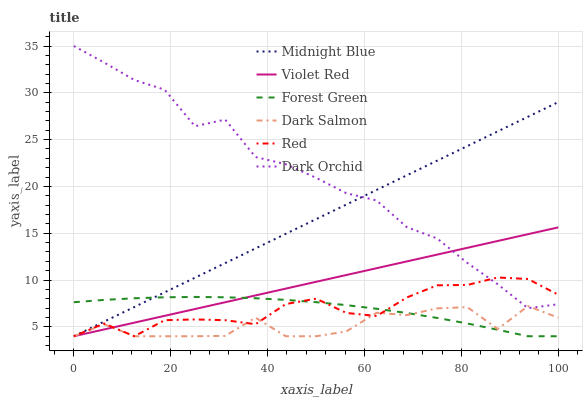Does Dark Salmon have the minimum area under the curve?
Answer yes or no. Yes. Does Dark Orchid have the maximum area under the curve?
Answer yes or no. Yes. Does Midnight Blue have the minimum area under the curve?
Answer yes or no. No. Does Midnight Blue have the maximum area under the curve?
Answer yes or no. No. Is Violet Red the smoothest?
Answer yes or no. Yes. Is Dark Salmon the roughest?
Answer yes or no. Yes. Is Midnight Blue the smoothest?
Answer yes or no. No. Is Midnight Blue the roughest?
Answer yes or no. No. Does Violet Red have the lowest value?
Answer yes or no. Yes. Does Dark Orchid have the lowest value?
Answer yes or no. No. Does Dark Orchid have the highest value?
Answer yes or no. Yes. Does Midnight Blue have the highest value?
Answer yes or no. No. Is Forest Green less than Dark Orchid?
Answer yes or no. Yes. Is Dark Orchid greater than Forest Green?
Answer yes or no. Yes. Does Midnight Blue intersect Dark Salmon?
Answer yes or no. Yes. Is Midnight Blue less than Dark Salmon?
Answer yes or no. No. Is Midnight Blue greater than Dark Salmon?
Answer yes or no. No. Does Forest Green intersect Dark Orchid?
Answer yes or no. No. 